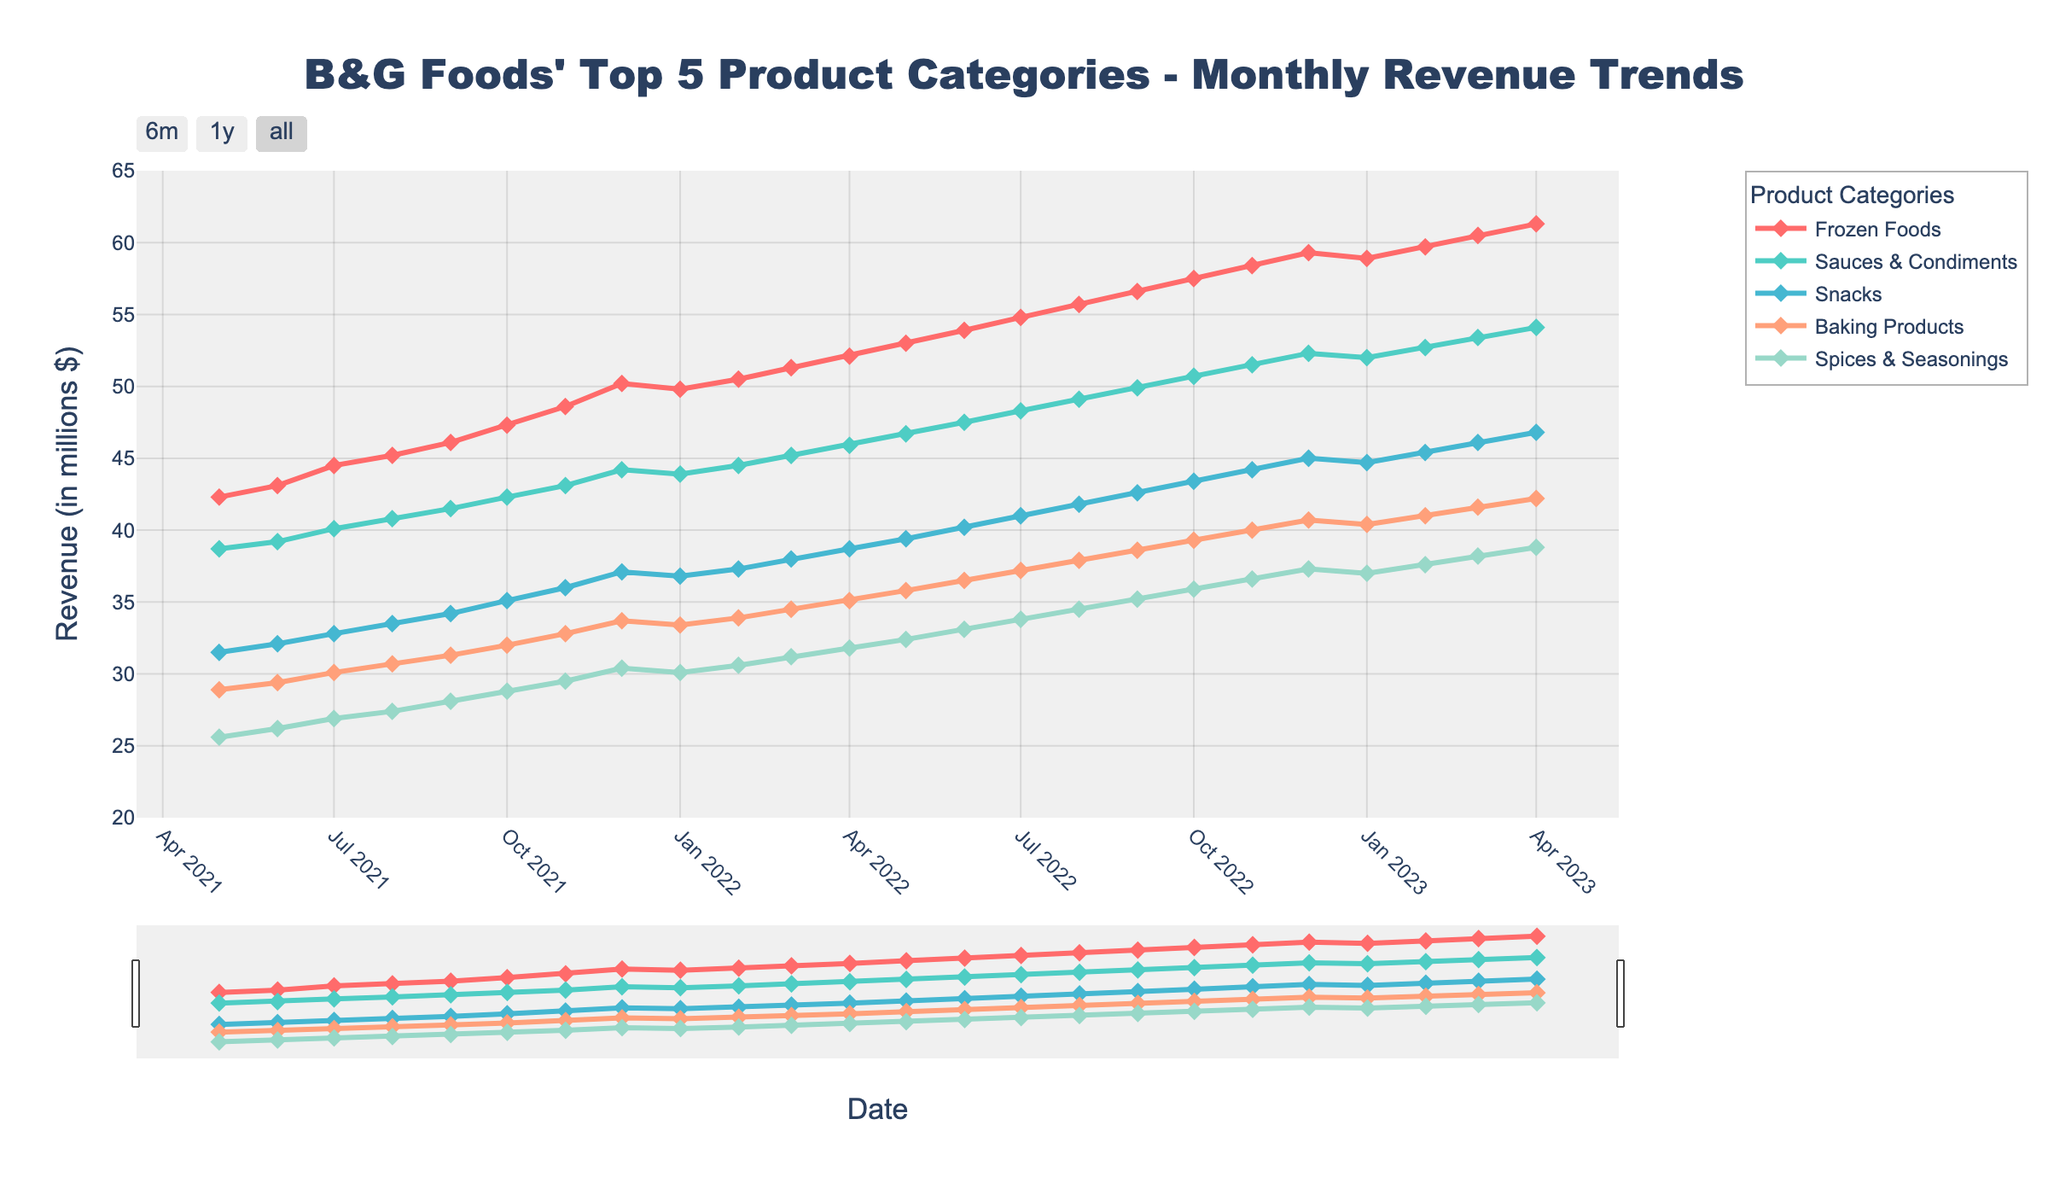what's the month with the highest revenue for Frozen Foods? The line representing Frozen Foods reaches its highest point in April 2023. The y-value at this point reveals the highest revenue.
Answer: April 2023 which product category had the fastest revenue growth over the 2 years? By comparing the slopes of the lines for each category, the line for Frozen Foods has the steepest upward trend from May 2021 to April 2023, indicating the fastest growth.
Answer: Frozen Foods how much did the revenue for Spices & Seasonings increase from May 2021 to April 2023? In May 2021, Spices & Seasonings is at 25.6 million dollars and in April 2023 it reaches 38.8 million dollars. The increase is 38.8 - 25.6.
Answer: 13.2 million dollars which two product categories had almost equal revenues in December 2021? The lines for Sauces & Condiments and Snacks intersect around December 2021, indicating similar revenues. Checking the exact y-values shows they are close.
Answer: Sauces & Condiments and Snacks does Baking Products or Snacks have a more stable revenue trend? By comparing the variability of the lines over time, the Snacks line fluctuates less than the Baking Products line.
Answer: Snacks what's the difference in revenue between Frozen Foods and Snacks in December 2022? Frozen Foods has a revenue of 59.3 million dollars, and Snacks has 45.0 million dollars in December 2022. The difference is 59.3 - 45.0.
Answer: 14.3 million dollars which product category reached 50 million dollars in revenue first? The Frozen Foods line crosses the 50 million dollars mark before other categories, around December 2021.
Answer: Frozen Foods what time period shows the most substantial revenue growth for Baking Products? Observing the slope changes, the period from May 2021 to January 2023 shows the most significant increase for Baking Products.
Answer: May 2021 to January 2023 what is the combined revenue of Sauces & Condiments and Snacks in March 2022? In March 2022, Sauces & Condiments is at 45.2 million dollars and Snacks is at 38.0 million dollars. The combined revenue is 45.2 + 38.0.
Answer: 83.2 million dollars did any product category experience a revenue decline? All lines show a consistent upward trend; hence, no product category experienced a revenue decline.
Answer: None 